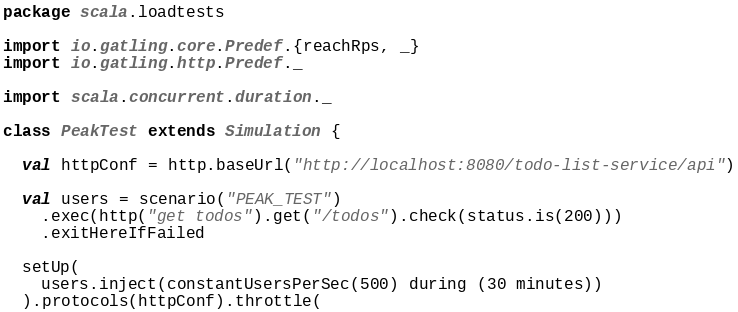<code> <loc_0><loc_0><loc_500><loc_500><_Scala_>package scala.loadtests

import io.gatling.core.Predef.{reachRps, _}
import io.gatling.http.Predef._

import scala.concurrent.duration._

class PeakTest extends Simulation {

  val httpConf = http.baseUrl("http://localhost:8080/todo-list-service/api")

  val users = scenario("PEAK_TEST")
    .exec(http("get todos").get("/todos").check(status.is(200)))
    .exitHereIfFailed

  setUp(
    users.inject(constantUsersPerSec(500) during (30 minutes))
  ).protocols(httpConf).throttle(</code> 